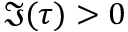Convert formula to latex. <formula><loc_0><loc_0><loc_500><loc_500>\Im ( \tau ) > 0</formula> 